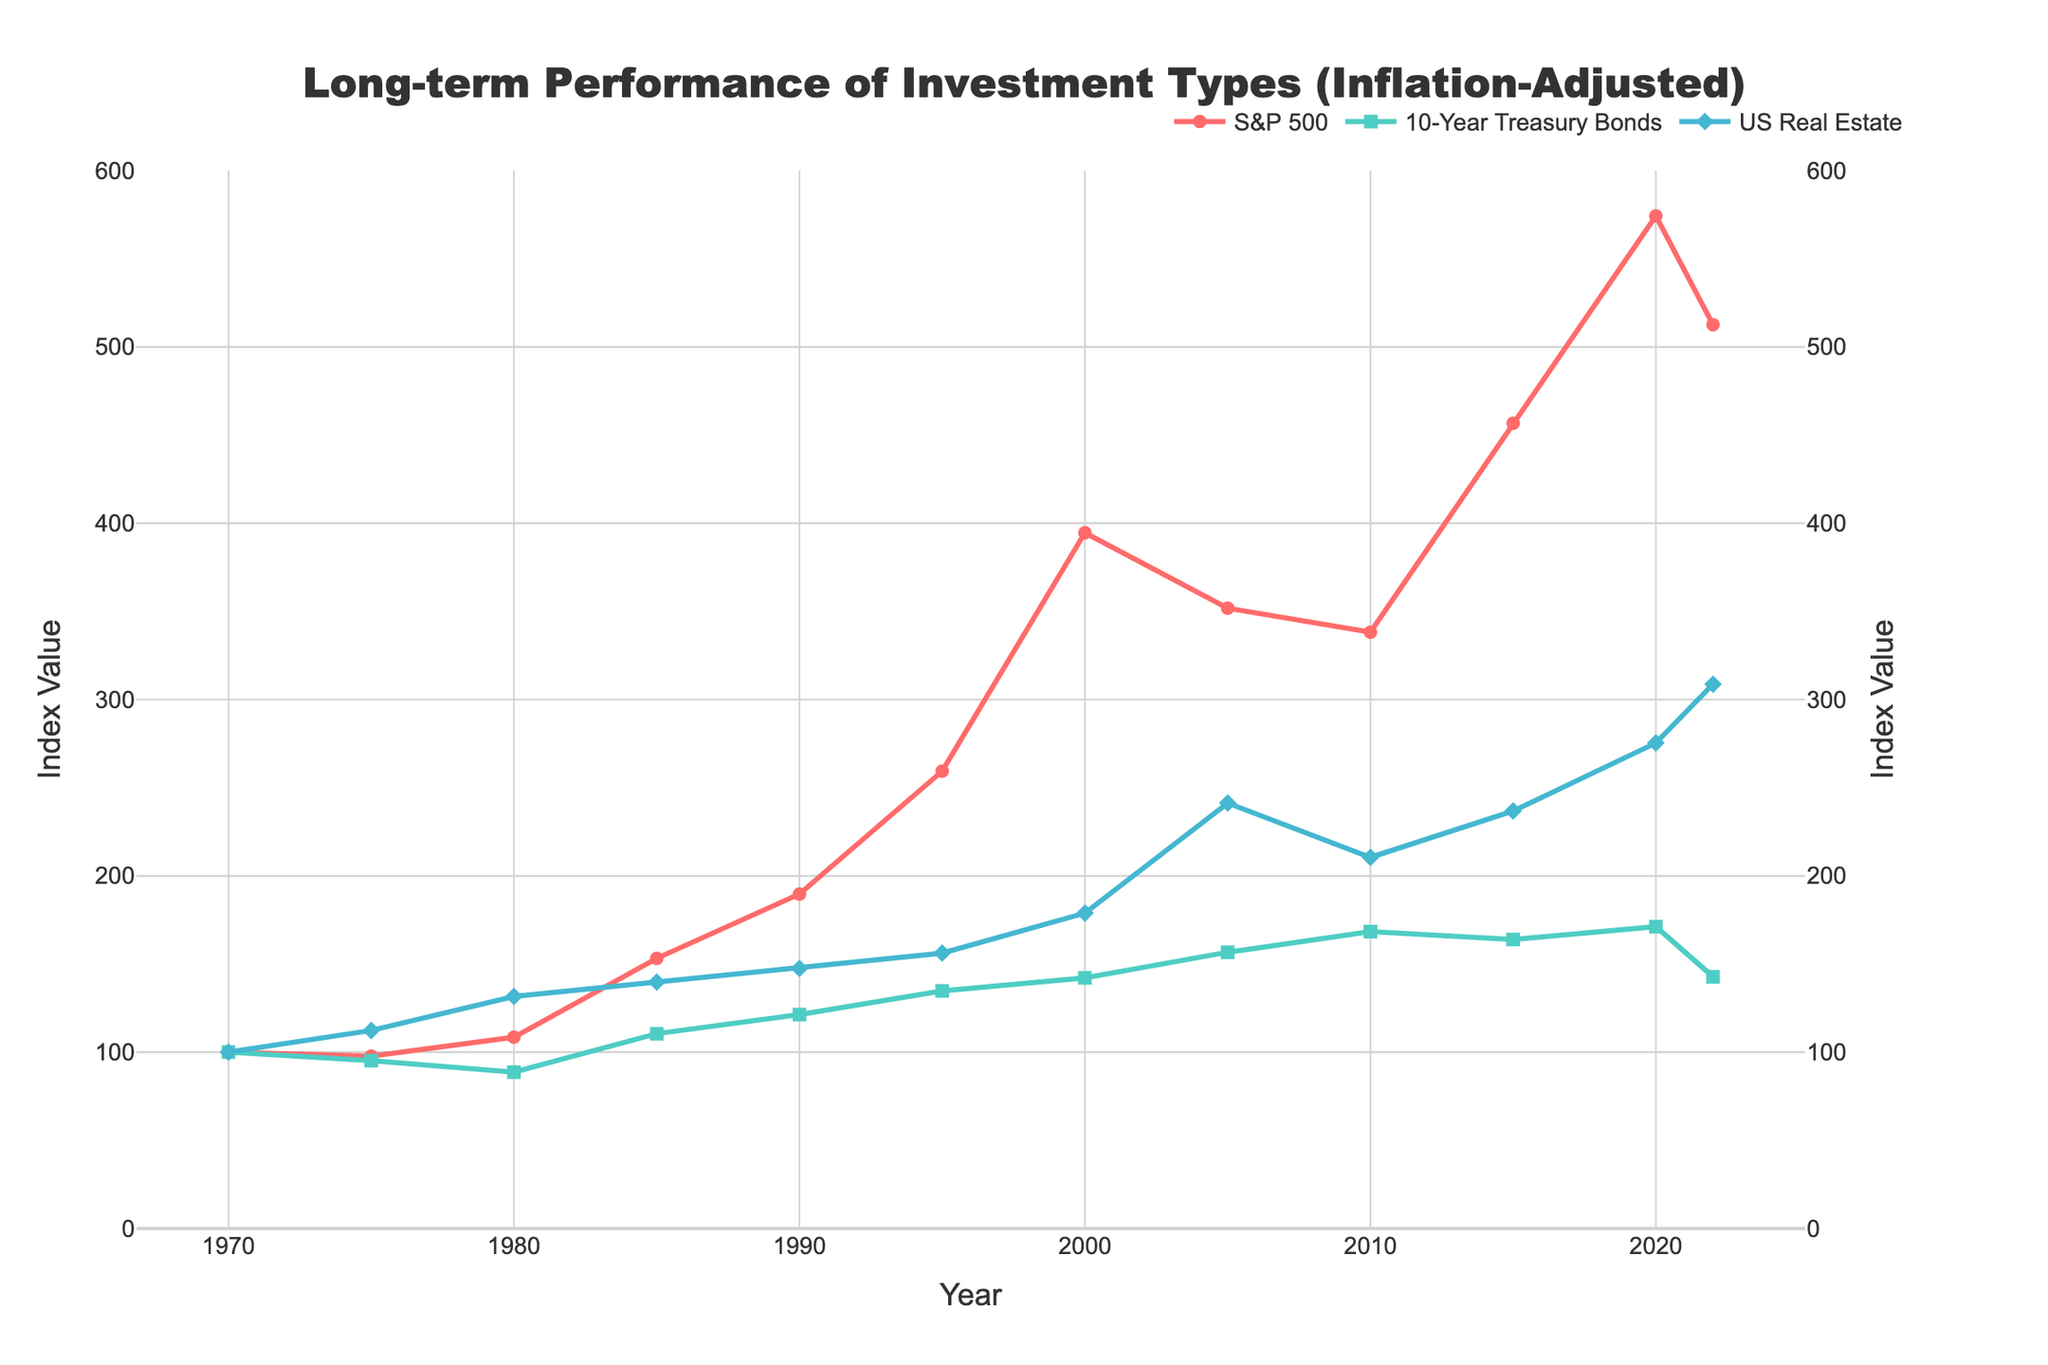Which investment type had the highest end value in 2022? The chart shows three investment types with their inflation-adjusted values over the years. The end value in 2022 for US Real Estate appears to be the highest among the three.
Answer: US Real Estate How did the S&P 500 perform between 2000 and 2020? The chart shows that the S&P 500 started at 394.6 in 2000, declined to 351.8 in 2005, slightly decreased further to 338.2 in 2010, but then significantly increased to 574.3 in 2020. Overall, it shows a strong upward trend with some fluctuations in between.
Answer: Increased Between 1990 and 2010, which investment type saw the smallest increase? The chart shows 10-Year Treasury Bonds increased from 121.3 in 1990 to 168.4 in 2010, S&P 500 increased from 189.7 to 338.2, and US Real Estate increased from 147.5 to 210.5. The smallest increase was in US Real Estate.
Answer: US Real Estate Compare the performance of US Real Estate to 10-Year Treasury Bonds in 2000. In 2000, US Real Estate had an index value of 178.9, while 10-Year Treasury Bonds had a value of 142.1. US Real Estate had a higher value than 10-Year Treasury Bonds in that year.
Answer: US Real Estate had a higher value What is the range of the S&P 500 index value over the years shown? The chart's y-axis for the S&P 500 shows values ranging from its minimum in 1975 (97.8) to its maximum in 2020 (574.3). The range is 574.3 - 97.8.
Answer: 476.5 During which period did the 10-Year Treasury Bonds show the most stagnation or decline? By examining the 10-Year Treasury Bonds line, the period from 1970 to 1980 shows stagnation or decline, as its value decreased from 100 to 88.7.
Answer: 1970 to 1980 What's the visual difference in marker shapes between 10-Year Treasury Bonds and S&P 500? The chart uses different marker shapes to distinguish data points. The 10-Year Treasury Bonds are depicted with squares, while the S&P 500 uses circles.
Answer: Squares vs Circles Which investment had the most consistent upward trend since 2010? Observing the chart, the S&P 500 shows a steep and consistent upward trend since 2010, reaching a peak in 2020.
Answer: S&P 500 How does the visual color of the S&P 500 line help identify it in the chart? The chart uses distinct colors for each line, and the S&P 500 is represented by a red line, making it easily distinguishable from the others.
Answer: Red 